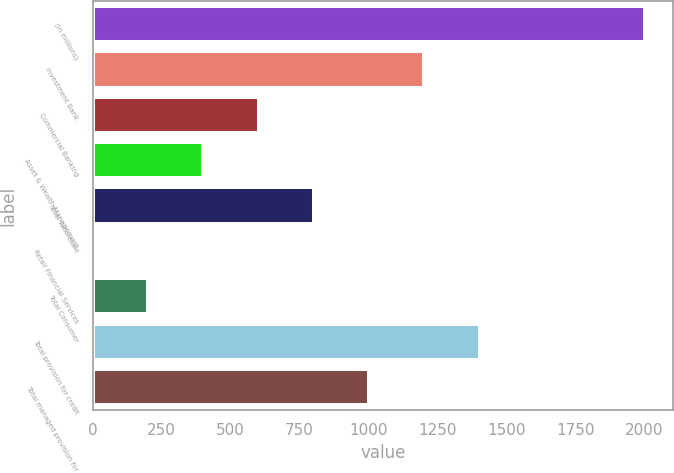Convert chart. <chart><loc_0><loc_0><loc_500><loc_500><bar_chart><fcel>(in millions)<fcel>Investment Bank<fcel>Commercial Banking<fcel>Asset & Wealth Management<fcel>Total Wholesale<fcel>Retail Financial Services<fcel>Total Consumer<fcel>Total provision for credit<fcel>Total managed provision for<nl><fcel>2004<fcel>1202.8<fcel>601.9<fcel>401.6<fcel>802.2<fcel>1<fcel>201.3<fcel>1403.1<fcel>1002.5<nl></chart> 